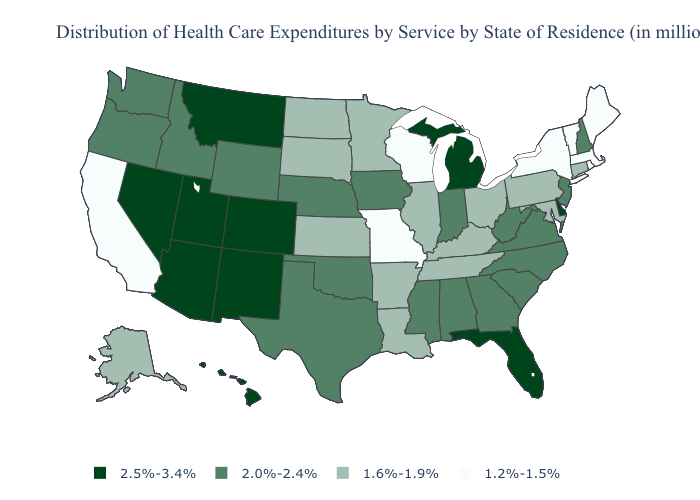Does Nebraska have a higher value than South Dakota?
Write a very short answer. Yes. Name the states that have a value in the range 1.6%-1.9%?
Be succinct. Alaska, Arkansas, Connecticut, Illinois, Kansas, Kentucky, Louisiana, Maryland, Minnesota, North Dakota, Ohio, Pennsylvania, South Dakota, Tennessee. Does New Mexico have a lower value than Montana?
Answer briefly. No. Name the states that have a value in the range 1.6%-1.9%?
Write a very short answer. Alaska, Arkansas, Connecticut, Illinois, Kansas, Kentucky, Louisiana, Maryland, Minnesota, North Dakota, Ohio, Pennsylvania, South Dakota, Tennessee. Name the states that have a value in the range 2.5%-3.4%?
Answer briefly. Arizona, Colorado, Delaware, Florida, Hawaii, Michigan, Montana, Nevada, New Mexico, Utah. What is the lowest value in the USA?
Write a very short answer. 1.2%-1.5%. What is the value of Wyoming?
Write a very short answer. 2.0%-2.4%. Which states have the highest value in the USA?
Concise answer only. Arizona, Colorado, Delaware, Florida, Hawaii, Michigan, Montana, Nevada, New Mexico, Utah. Which states have the lowest value in the Northeast?
Be succinct. Maine, Massachusetts, New York, Rhode Island, Vermont. How many symbols are there in the legend?
Answer briefly. 4. What is the value of South Dakota?
Answer briefly. 1.6%-1.9%. Does the first symbol in the legend represent the smallest category?
Be succinct. No. Which states have the lowest value in the Northeast?
Be succinct. Maine, Massachusetts, New York, Rhode Island, Vermont. Name the states that have a value in the range 2.5%-3.4%?
Write a very short answer. Arizona, Colorado, Delaware, Florida, Hawaii, Michigan, Montana, Nevada, New Mexico, Utah. What is the lowest value in the USA?
Quick response, please. 1.2%-1.5%. 